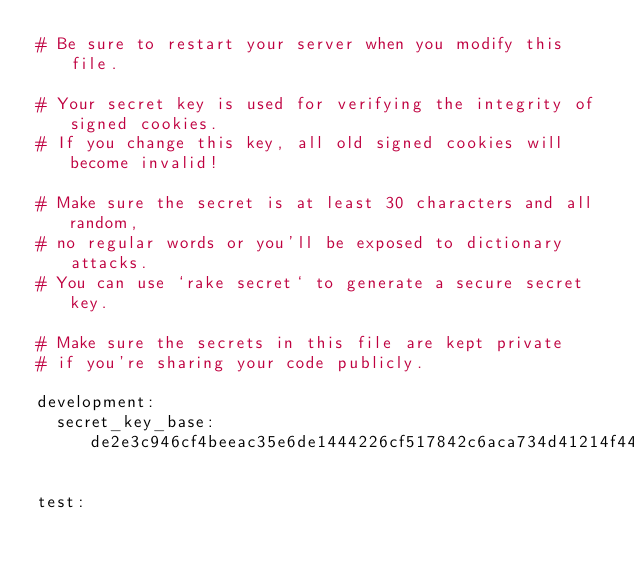Convert code to text. <code><loc_0><loc_0><loc_500><loc_500><_YAML_># Be sure to restart your server when you modify this file.

# Your secret key is used for verifying the integrity of signed cookies.
# If you change this key, all old signed cookies will become invalid!

# Make sure the secret is at least 30 characters and all random,
# no regular words or you'll be exposed to dictionary attacks.
# You can use `rake secret` to generate a secure secret key.

# Make sure the secrets in this file are kept private
# if you're sharing your code publicly.

development:
  secret_key_base: de2e3c946cf4beeac35e6de1444226cf517842c6aca734d41214f44f14e6d5bf1264763abab30b08e96d55cf4242eabe7febd1ca7dcf44221f6352e69b544c2a

test:</code> 